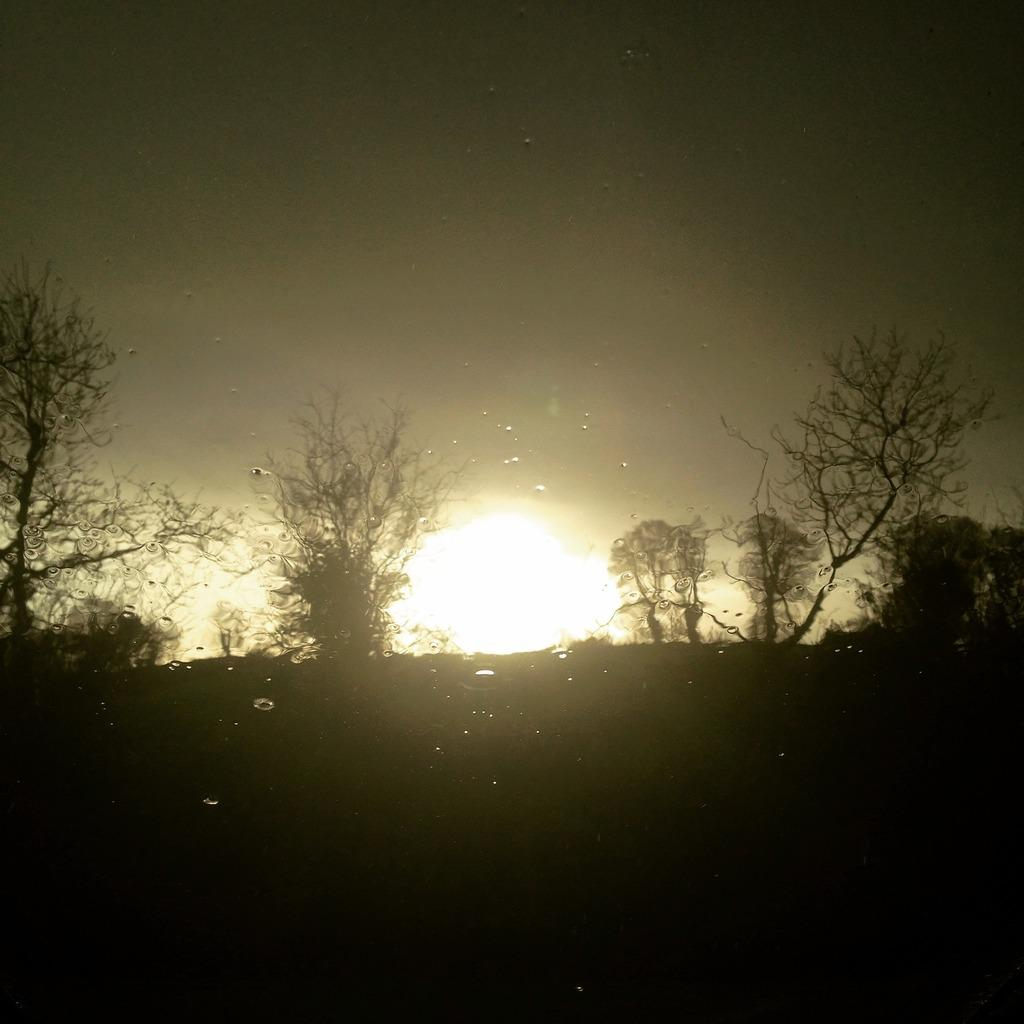What is the color or tone of the bottom of the image? The bottom of the image is dark. What type of vegetation can be seen in the image? There are trees visible in the image. Can the sun be seen in the image? Yes, the sun is observable in the image. What part of the natural environment is visible in the image? The sky is visible in the image. What type of cord is hanging from the tree in the image? There is no cord hanging from the tree in the image. What type of berry is growing on the trees in the image? There is no mention of berries growing on the trees in the image. Is there a porter carrying luggage in the image? There is no reference to a porter or luggage in the image. 